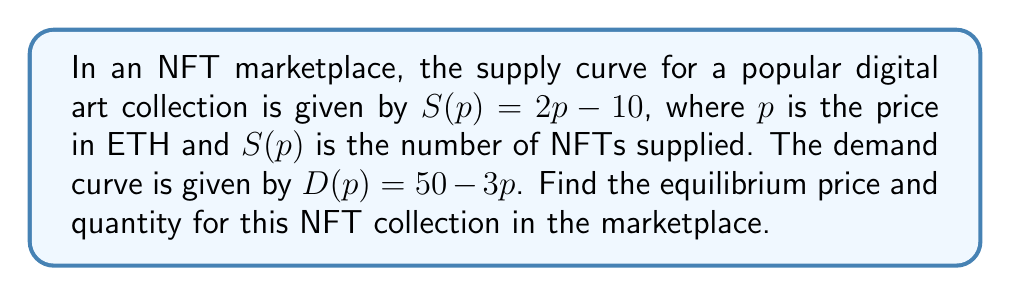Teach me how to tackle this problem. To find the intersection point of the supply and demand curves, we need to solve the equation where supply equals demand:

$$S(p) = D(p)$$

Substituting the given equations:

$$2p - 10 = 50 - 3p$$

Now, let's solve this equation step by step:

1) Add 10 to both sides:
   $$2p = 60 - 3p$$

2) Add 3p to both sides:
   $$5p = 60$$

3) Divide both sides by 5:
   $$p = 12$$

This gives us the equilibrium price. To find the equilibrium quantity, we can substitute this price into either the supply or demand equation. Let's use the supply equation:

$$S(12) = 2(12) - 10 = 24 - 10 = 14$$

Therefore, the equilibrium point occurs at a price of 12 ETH and a quantity of 14 NFTs.

[asy]
import graph;
size(200,200);
real f(real x) {return 2x - 10;}
real g(real x) {return 50 - 3x;}
draw(graph(f,0,20),blue);
draw(graph(g,0,20),red);
dot((12,14));
label("Supply",(-1,30),blue);
label("Demand",(20,10),red);
label("(12, 14)",(12,14),NE);
xaxis("Price (ETH)",arrow=Arrow);
yaxis("Quantity",arrow=Arrow);
[/asy]
Answer: The equilibrium price is 12 ETH, and the equilibrium quantity is 14 NFTs. 